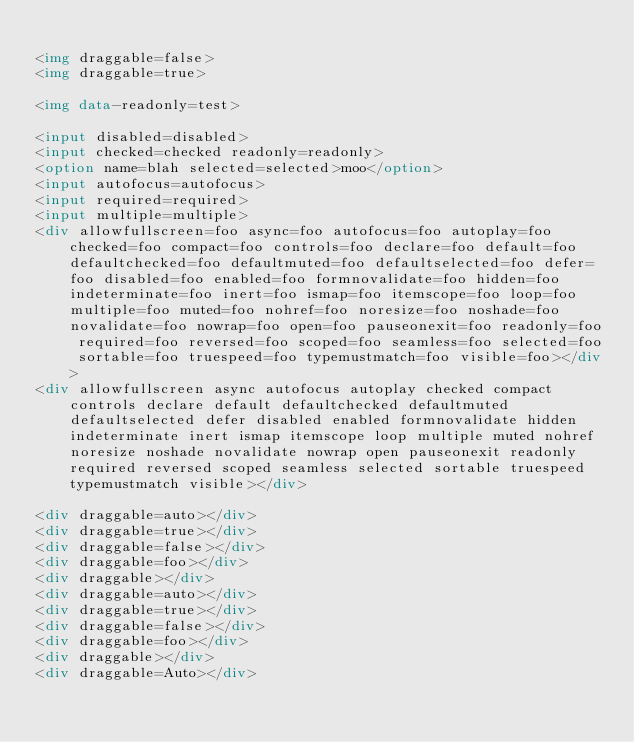Convert code to text. <code><loc_0><loc_0><loc_500><loc_500><_HTML_>
<img draggable=false>
<img draggable=true>

<img data-readonly=test>

<input disabled=disabled>
<input checked=checked readonly=readonly>
<option name=blah selected=selected>moo</option>
<input autofocus=autofocus>
<input required=required>
<input multiple=multiple>
<div allowfullscreen=foo async=foo autofocus=foo autoplay=foo checked=foo compact=foo controls=foo declare=foo default=foo defaultchecked=foo defaultmuted=foo defaultselected=foo defer=foo disabled=foo enabled=foo formnovalidate=foo hidden=foo indeterminate=foo inert=foo ismap=foo itemscope=foo loop=foo multiple=foo muted=foo nohref=foo noresize=foo noshade=foo novalidate=foo nowrap=foo open=foo pauseonexit=foo readonly=foo required=foo reversed=foo scoped=foo seamless=foo selected=foo sortable=foo truespeed=foo typemustmatch=foo visible=foo></div>
<div allowfullscreen async autofocus autoplay checked compact controls declare default defaultchecked defaultmuted defaultselected defer disabled enabled formnovalidate hidden indeterminate inert ismap itemscope loop multiple muted nohref noresize noshade novalidate nowrap open pauseonexit readonly required reversed scoped seamless selected sortable truespeed typemustmatch visible></div>

<div draggable=auto></div>
<div draggable=true></div>
<div draggable=false></div>
<div draggable=foo></div>
<div draggable></div>
<div draggable=auto></div>
<div draggable=true></div>
<div draggable=false></div>
<div draggable=foo></div>
<div draggable></div>
<div draggable=Auto></div>


</code> 